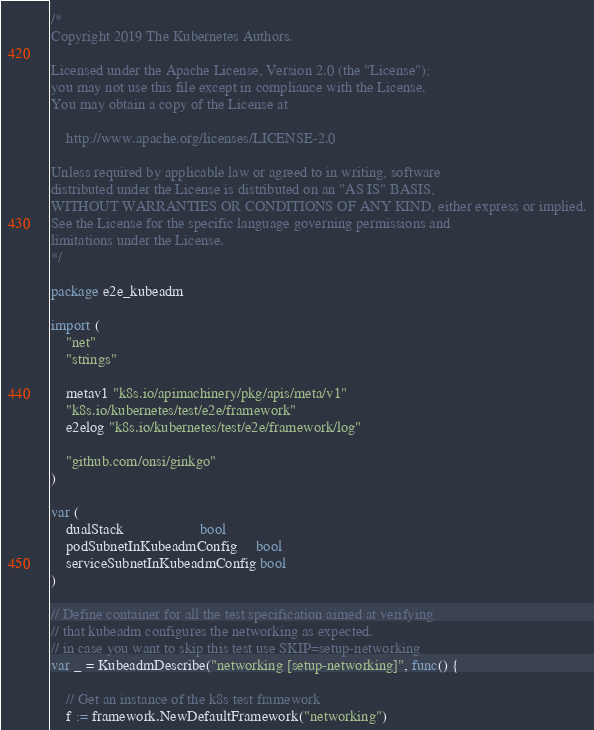Convert code to text. <code><loc_0><loc_0><loc_500><loc_500><_Go_>/*
Copyright 2019 The Kubernetes Authors.

Licensed under the Apache License, Version 2.0 (the "License");
you may not use this file except in compliance with the License.
You may obtain a copy of the License at

    http://www.apache.org/licenses/LICENSE-2.0

Unless required by applicable law or agreed to in writing, software
distributed under the License is distributed on an "AS IS" BASIS,
WITHOUT WARRANTIES OR CONDITIONS OF ANY KIND, either express or implied.
See the License for the specific language governing permissions and
limitations under the License.
*/

package e2e_kubeadm

import (
	"net"
	"strings"

	metav1 "k8s.io/apimachinery/pkg/apis/meta/v1"
	"k8s.io/kubernetes/test/e2e/framework"
	e2elog "k8s.io/kubernetes/test/e2e/framework/log"

	"github.com/onsi/ginkgo"
)

var (
	dualStack                    bool
	podSubnetInKubeadmConfig     bool
	serviceSubnetInKubeadmConfig bool
)

// Define container for all the test specification aimed at verifying
// that kubeadm configures the networking as expected.
// in case you want to skip this test use SKIP=setup-networking
var _ = KubeadmDescribe("networking [setup-networking]", func() {

	// Get an instance of the k8s test framework
	f := framework.NewDefaultFramework("networking")
</code> 